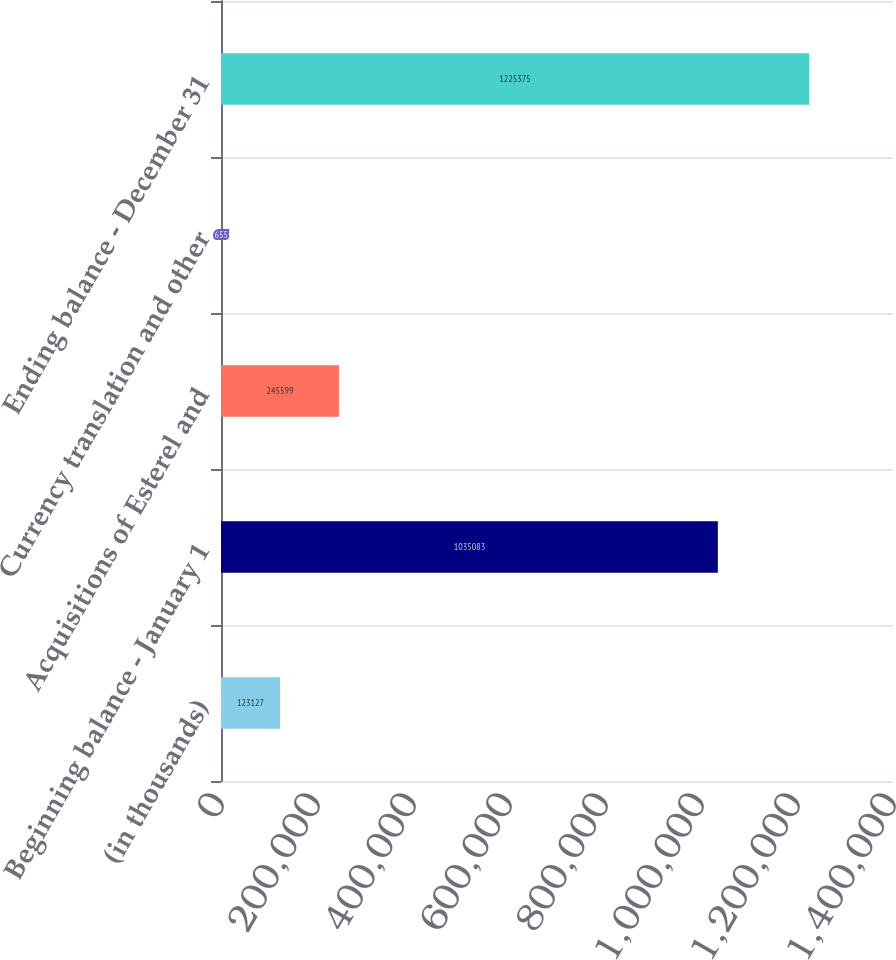Convert chart to OTSL. <chart><loc_0><loc_0><loc_500><loc_500><bar_chart><fcel>(in thousands)<fcel>Beginning balance - January 1<fcel>Acquisitions of Esterel and<fcel>Currency translation and other<fcel>Ending balance - December 31<nl><fcel>123127<fcel>1.03508e+06<fcel>245599<fcel>655<fcel>1.22538e+06<nl></chart> 